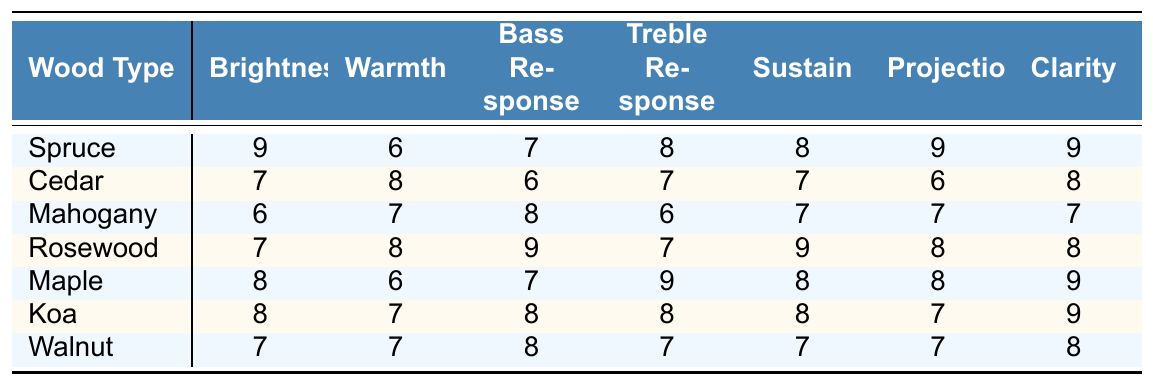What wood type has the highest brightness score? Looking at the "Brightness" column, the highest score is 9, which is associated with Spruce.
Answer: Spruce Which wood type is known for its warmth? The "Warmth" column shows that Cedar has the highest score of 8, indicating it’s known for its warmth.
Answer: Cedar What is the average projection score among all the wood types? The projection scores are 9, 6, 7, 8, 8, 7, and 7. Summing these gives 52. Dividing by 7 (the number of wood types) results in an average of 52/7 ≈ 7.43.
Answer: Approximately 7.43 Does Rosewood have a better bass response than Mahogany? Rosewood has a bass response score of 9, while Mahogany has a score of 8. Therefore, Rosewood has a better bass response than Mahogany.
Answer: Yes Which wood types have a treble response score of 8 or higher? The treble response scores are as follows: Spruce (8), Rosewood (7), Maple (9), Koa (8). The wood types with scores of 8 or higher are Spruce, Maple, and Koa.
Answer: Spruce, Maple, Koa What is the difference in sustain scores between Maple and Walnut? Maple has a sustain score of 8 and Walnut has a score of 7. The difference is 8 - 7 = 1.
Answer: 1 Which wood type has the lowest clarity score? Looking at the "Clarity" column, the lowest score is 7, found in Mahogany and Walnut.
Answer: Mahogany, Walnut If a guitar made of Cedar is compared with one made of Spruce, which would have a better projection? Cedar has a projection score of 6 and Spruce has a score of 9. Since 9 is greater than 6, Spruce would have better projection.
Answer: Spruce What tonal quality has the highest average score among all wood types? The scores for each tonal quality are as follows: Brightness (7.43), Warmth (7.29), Bass Response (7.57), Treble Response (7.71), Sustain (7.71), Projection (7.43), and Clarity (8). The average scores show that Clarity has the highest score of 8.
Answer: Clarity Which wood type is most associated with bass response based on the scores? The "Bass Response" column shows that Rosewood has the highest score of 9, indicating it’s most associated with bass response.
Answer: Rosewood 